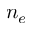Convert formula to latex. <formula><loc_0><loc_0><loc_500><loc_500>n _ { e }</formula> 